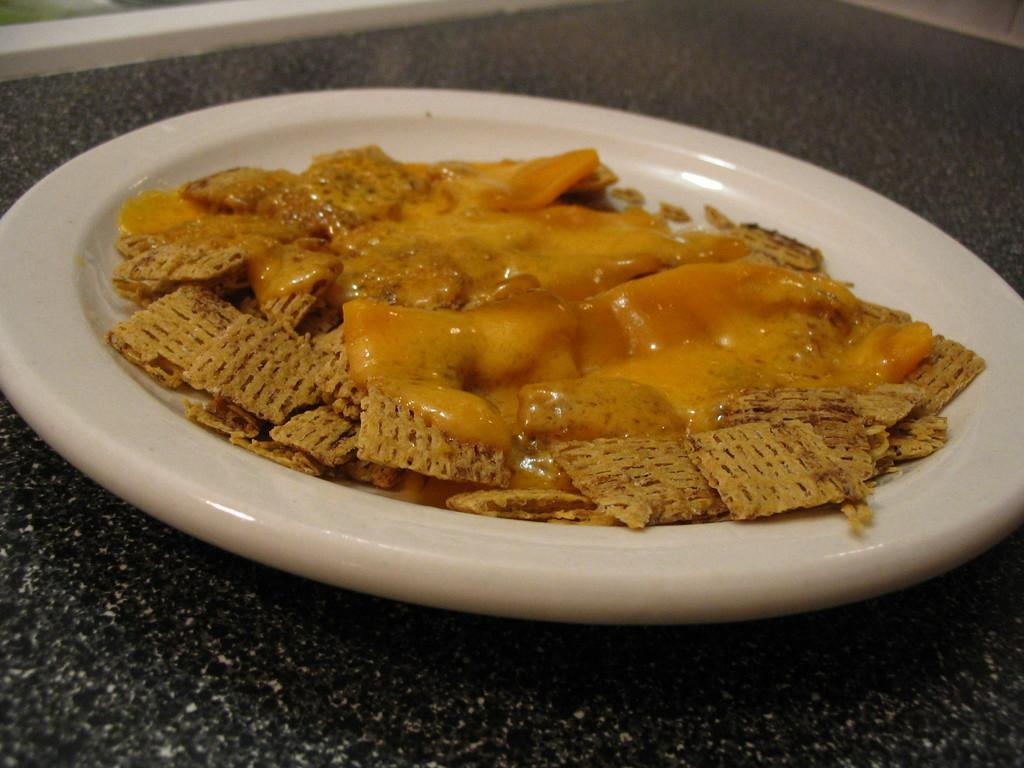What is the color of the surface in the image? The surface in the image is black. What is placed on the surface? There is a white plate on the surface. What is on the plate? There is a food item on the plate. What can be seen on the food item? The food item has cream on it. How many books are stacked on the plate in the image? There are no books present in the image; it features a black surface with a white plate and a food item with cream on it. 